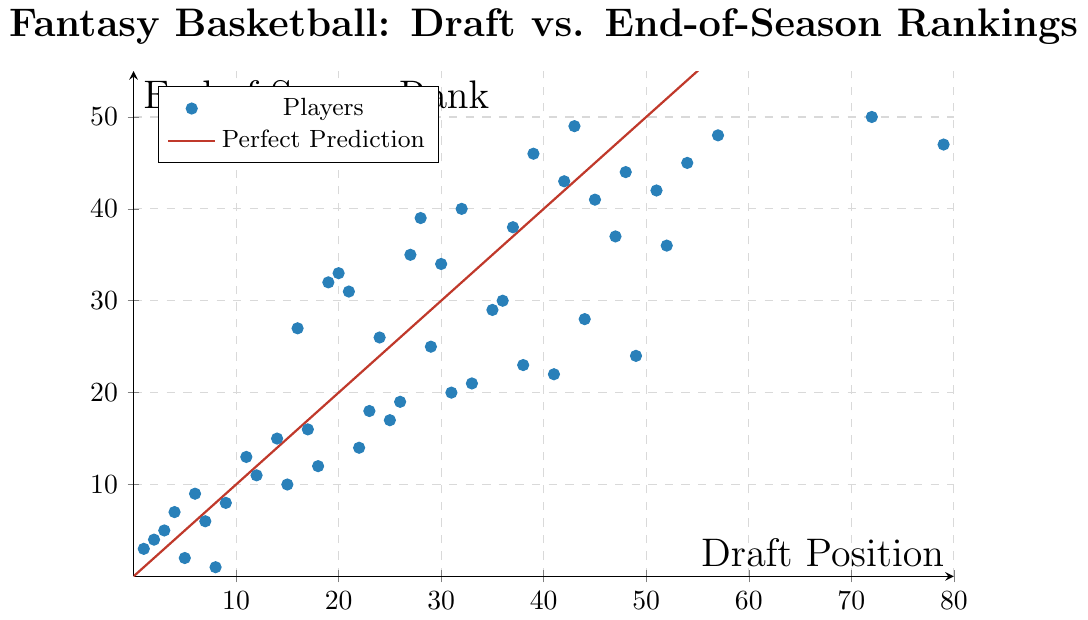What's the draft position of the player who ended the season ranked first? To find this, look for the data point labeled with an end-of-season rank of 1. From the plot, Giannis Antetokounmpo has an end-of-season rank of 1 and a draft position of 8.
Answer: 8 Which player had the largest difference between draft position and end-of-season rank? To determine this, calculate the difference between draft position and end-of-season rank for each player and find the maximum value. The largest difference on the plot is for Josh Richardson, with a draft position of 79 and an end-of-season rank of 47. The difference is 32.
Answer: Josh Richardson How many players finished the season within 10 positions of their draft spot? Review the plot and count the number of points that fall within a margin of 10 units from the line y = x, which signifies no change. This counts players whose end-of-season rank is within ±10 of their draft position. Counting these points gives 30 players.
Answer: 30 Compare the draft positions versus the end-of-season rankings for LeBron James and Stephen Curry. Who outperformed their draft position more significantly? LeBron James has a draft position of 1 and an end-of-season rank of 3 (difference of 2), while Stephen Curry has a draft position of 5 and an end-of-season rank of 2 (difference of 3). Stephen Curry outperformed his draft position more significantly.
Answer: Stephen Curry Identify and list the players who ended the season ranked better than their draft position. Identify points below the line y = x (where the end-of-season rank is less than the draft position). These players include Giannis Antetokounmpo, Stephen Curry, Karl-Anthony Towns, and others who are below the line on the plot. There are 20 such players.
Answer: 20 What is the median end-of-season rank for players with a draft position greater than 30? First, filter out players whose draft positions are greater than 30. Then, find the median among their end-of-season ranks. For the players meeting the criteria, the end-of-season ranks are {20, 21, 22, 23, 24, 25, 28, 29, 30, 31, 32, 33, 34, 35, 36, 37, 38, 41, 42, 43, 44, 45, 46, 47, 48, 49, 50}. The median of these values (27 data points) is the 14th value, which is 33.
Answer: 33 How does the performance of players drafted in the top 10 compare to players drafted between positions 40 and 50? Compare the average end-of-season rank of the top 10 draft picks versus those drafted between 40 and 50. Top 10 draft picks have ranks {3, 2, 4, 1, 5, 7, 6, 9, 8, 10}, average is (3+2+4+1+5+7+6+9+8+10)/10 = 5.5. For positions 40-50: ranks are {22, 23, 24, 36, 37, 38, 41, 42, 43, 44}, average is (22+23+24+36+37+38+41+42+43+44)/10 = 35.
Answer: Top 10: 5.5, 40-50: 35 